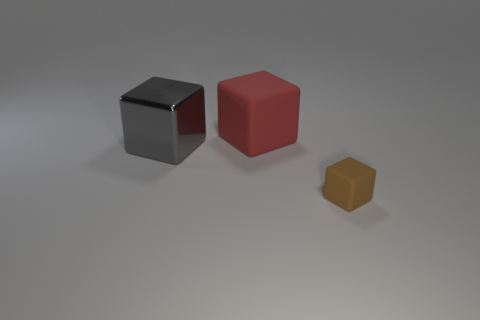Is there anything else that has the same material as the gray cube?
Your answer should be compact. No. There is a large red thing; how many shiny cubes are left of it?
Offer a terse response. 1. What number of big objects have the same material as the small cube?
Provide a succinct answer. 1. Are the big cube to the left of the big rubber block and the tiny brown block made of the same material?
Make the answer very short. No. Are any red rubber cubes visible?
Your response must be concise. Yes. What size is the block that is both on the right side of the gray metal cube and in front of the large matte cube?
Ensure brevity in your answer.  Small. Are there more large gray metallic things that are in front of the red cube than brown matte things that are behind the tiny brown block?
Provide a succinct answer. Yes. The tiny thing has what color?
Your answer should be compact. Brown. What is the color of the object that is both behind the tiny brown matte block and to the right of the big gray shiny cube?
Offer a terse response. Red. What color is the cube on the left side of the rubber block that is behind the matte thing that is in front of the big gray cube?
Offer a very short reply. Gray. 